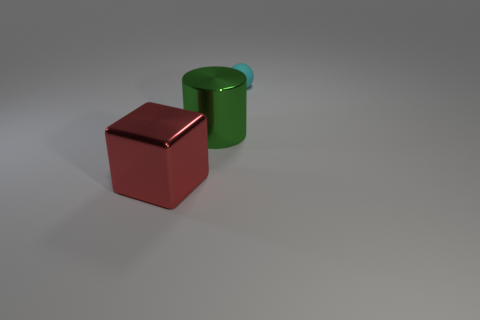Add 2 small objects. How many objects exist? 5 Subtract all blocks. How many objects are left? 2 Add 3 purple shiny objects. How many purple shiny objects exist? 3 Subtract 0 red balls. How many objects are left? 3 Subtract all blocks. Subtract all metallic cylinders. How many objects are left? 1 Add 3 small rubber objects. How many small rubber objects are left? 4 